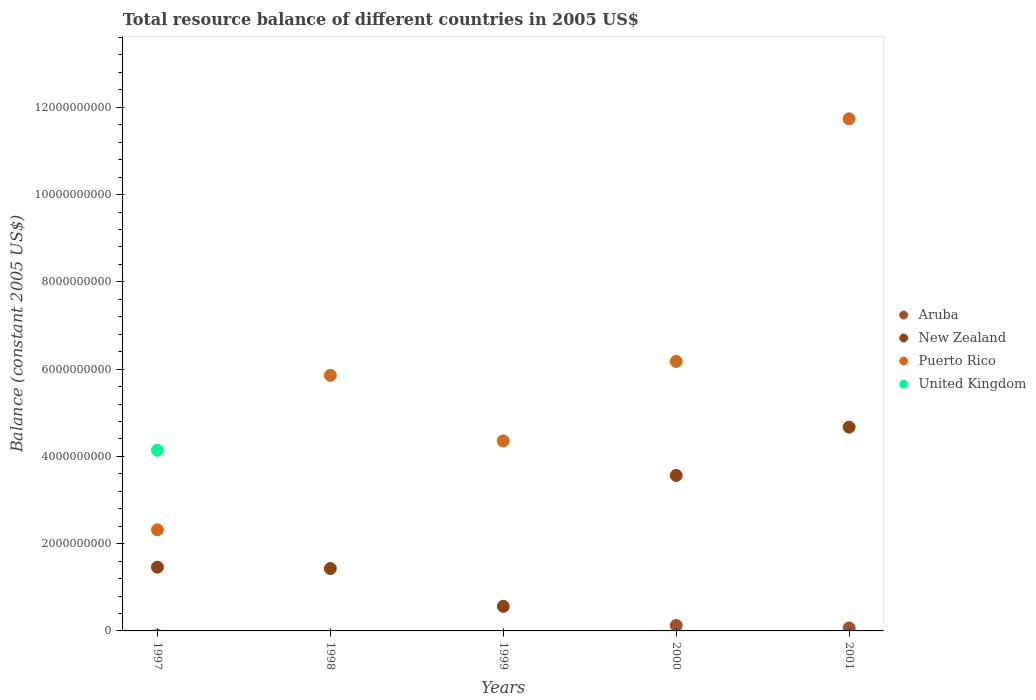How many different coloured dotlines are there?
Ensure brevity in your answer.  4. What is the total resource balance in Puerto Rico in 1999?
Your response must be concise. 4.35e+09. Across all years, what is the maximum total resource balance in New Zealand?
Keep it short and to the point. 4.67e+09. Across all years, what is the minimum total resource balance in New Zealand?
Your answer should be very brief. 5.63e+08. In which year was the total resource balance in United Kingdom maximum?
Your response must be concise. 1997. What is the total total resource balance in New Zealand in the graph?
Give a very brief answer. 1.17e+1. What is the difference between the total resource balance in New Zealand in 1999 and that in 2001?
Your answer should be very brief. -4.11e+09. What is the difference between the total resource balance in United Kingdom in 1997 and the total resource balance in Puerto Rico in 1999?
Provide a succinct answer. -2.14e+08. What is the average total resource balance in United Kingdom per year?
Your response must be concise. 8.28e+08. In the year 2001, what is the difference between the total resource balance in Puerto Rico and total resource balance in New Zealand?
Provide a succinct answer. 7.07e+09. What is the ratio of the total resource balance in New Zealand in 1999 to that in 2000?
Offer a very short reply. 0.16. Is the total resource balance in New Zealand in 1998 less than that in 2001?
Your answer should be compact. Yes. What is the difference between the highest and the second highest total resource balance in Puerto Rico?
Make the answer very short. 5.56e+09. What is the difference between the highest and the lowest total resource balance in Aruba?
Your answer should be compact. 1.24e+08. In how many years, is the total resource balance in Puerto Rico greater than the average total resource balance in Puerto Rico taken over all years?
Offer a terse response. 2. Is it the case that in every year, the sum of the total resource balance in New Zealand and total resource balance in Puerto Rico  is greater than the sum of total resource balance in United Kingdom and total resource balance in Aruba?
Your answer should be very brief. No. Is it the case that in every year, the sum of the total resource balance in Puerto Rico and total resource balance in United Kingdom  is greater than the total resource balance in Aruba?
Ensure brevity in your answer.  Yes. Does the total resource balance in New Zealand monotonically increase over the years?
Your answer should be compact. No. Is the total resource balance in United Kingdom strictly greater than the total resource balance in Puerto Rico over the years?
Your response must be concise. No. Is the total resource balance in Puerto Rico strictly less than the total resource balance in New Zealand over the years?
Your response must be concise. No. How many dotlines are there?
Offer a very short reply. 4. What is the difference between two consecutive major ticks on the Y-axis?
Make the answer very short. 2.00e+09. Are the values on the major ticks of Y-axis written in scientific E-notation?
Offer a terse response. No. Does the graph contain any zero values?
Keep it short and to the point. Yes. What is the title of the graph?
Give a very brief answer. Total resource balance of different countries in 2005 US$. What is the label or title of the X-axis?
Give a very brief answer. Years. What is the label or title of the Y-axis?
Make the answer very short. Balance (constant 2005 US$). What is the Balance (constant 2005 US$) of Aruba in 1997?
Keep it short and to the point. 0. What is the Balance (constant 2005 US$) in New Zealand in 1997?
Give a very brief answer. 1.46e+09. What is the Balance (constant 2005 US$) in Puerto Rico in 1997?
Your answer should be very brief. 2.32e+09. What is the Balance (constant 2005 US$) in United Kingdom in 1997?
Your answer should be compact. 4.14e+09. What is the Balance (constant 2005 US$) in Aruba in 1998?
Offer a terse response. 0. What is the Balance (constant 2005 US$) of New Zealand in 1998?
Give a very brief answer. 1.43e+09. What is the Balance (constant 2005 US$) in Puerto Rico in 1998?
Your answer should be compact. 5.86e+09. What is the Balance (constant 2005 US$) of United Kingdom in 1998?
Give a very brief answer. 0. What is the Balance (constant 2005 US$) in Aruba in 1999?
Your answer should be very brief. 0. What is the Balance (constant 2005 US$) of New Zealand in 1999?
Ensure brevity in your answer.  5.63e+08. What is the Balance (constant 2005 US$) in Puerto Rico in 1999?
Provide a succinct answer. 4.35e+09. What is the Balance (constant 2005 US$) of United Kingdom in 1999?
Provide a succinct answer. 0. What is the Balance (constant 2005 US$) in Aruba in 2000?
Offer a terse response. 1.24e+08. What is the Balance (constant 2005 US$) of New Zealand in 2000?
Offer a terse response. 3.56e+09. What is the Balance (constant 2005 US$) in Puerto Rico in 2000?
Ensure brevity in your answer.  6.18e+09. What is the Balance (constant 2005 US$) in Aruba in 2001?
Your answer should be very brief. 6.72e+07. What is the Balance (constant 2005 US$) of New Zealand in 2001?
Keep it short and to the point. 4.67e+09. What is the Balance (constant 2005 US$) in Puerto Rico in 2001?
Make the answer very short. 1.17e+1. What is the Balance (constant 2005 US$) of United Kingdom in 2001?
Your answer should be compact. 0. Across all years, what is the maximum Balance (constant 2005 US$) in Aruba?
Make the answer very short. 1.24e+08. Across all years, what is the maximum Balance (constant 2005 US$) of New Zealand?
Provide a short and direct response. 4.67e+09. Across all years, what is the maximum Balance (constant 2005 US$) in Puerto Rico?
Your answer should be compact. 1.17e+1. Across all years, what is the maximum Balance (constant 2005 US$) in United Kingdom?
Give a very brief answer. 4.14e+09. Across all years, what is the minimum Balance (constant 2005 US$) of Aruba?
Your response must be concise. 0. Across all years, what is the minimum Balance (constant 2005 US$) of New Zealand?
Provide a short and direct response. 5.63e+08. Across all years, what is the minimum Balance (constant 2005 US$) of Puerto Rico?
Your response must be concise. 2.32e+09. Across all years, what is the minimum Balance (constant 2005 US$) in United Kingdom?
Keep it short and to the point. 0. What is the total Balance (constant 2005 US$) of Aruba in the graph?
Offer a terse response. 1.91e+08. What is the total Balance (constant 2005 US$) of New Zealand in the graph?
Offer a very short reply. 1.17e+1. What is the total Balance (constant 2005 US$) of Puerto Rico in the graph?
Make the answer very short. 3.04e+1. What is the total Balance (constant 2005 US$) in United Kingdom in the graph?
Ensure brevity in your answer.  4.14e+09. What is the difference between the Balance (constant 2005 US$) in New Zealand in 1997 and that in 1998?
Give a very brief answer. 3.16e+07. What is the difference between the Balance (constant 2005 US$) of Puerto Rico in 1997 and that in 1998?
Ensure brevity in your answer.  -3.54e+09. What is the difference between the Balance (constant 2005 US$) in New Zealand in 1997 and that in 1999?
Your answer should be compact. 8.98e+08. What is the difference between the Balance (constant 2005 US$) in Puerto Rico in 1997 and that in 1999?
Make the answer very short. -2.04e+09. What is the difference between the Balance (constant 2005 US$) in New Zealand in 1997 and that in 2000?
Keep it short and to the point. -2.10e+09. What is the difference between the Balance (constant 2005 US$) in Puerto Rico in 1997 and that in 2000?
Your response must be concise. -3.86e+09. What is the difference between the Balance (constant 2005 US$) in New Zealand in 1997 and that in 2001?
Your answer should be compact. -3.21e+09. What is the difference between the Balance (constant 2005 US$) of Puerto Rico in 1997 and that in 2001?
Your answer should be very brief. -9.42e+09. What is the difference between the Balance (constant 2005 US$) in New Zealand in 1998 and that in 1999?
Offer a very short reply. 8.67e+08. What is the difference between the Balance (constant 2005 US$) of Puerto Rico in 1998 and that in 1999?
Provide a short and direct response. 1.50e+09. What is the difference between the Balance (constant 2005 US$) of New Zealand in 1998 and that in 2000?
Your answer should be very brief. -2.13e+09. What is the difference between the Balance (constant 2005 US$) of Puerto Rico in 1998 and that in 2000?
Make the answer very short. -3.19e+08. What is the difference between the Balance (constant 2005 US$) of New Zealand in 1998 and that in 2001?
Your answer should be compact. -3.24e+09. What is the difference between the Balance (constant 2005 US$) in Puerto Rico in 1998 and that in 2001?
Your response must be concise. -5.88e+09. What is the difference between the Balance (constant 2005 US$) in New Zealand in 1999 and that in 2000?
Ensure brevity in your answer.  -3.00e+09. What is the difference between the Balance (constant 2005 US$) of Puerto Rico in 1999 and that in 2000?
Offer a very short reply. -1.82e+09. What is the difference between the Balance (constant 2005 US$) of New Zealand in 1999 and that in 2001?
Make the answer very short. -4.11e+09. What is the difference between the Balance (constant 2005 US$) of Puerto Rico in 1999 and that in 2001?
Provide a short and direct response. -7.38e+09. What is the difference between the Balance (constant 2005 US$) of Aruba in 2000 and that in 2001?
Your answer should be very brief. 5.69e+07. What is the difference between the Balance (constant 2005 US$) in New Zealand in 2000 and that in 2001?
Make the answer very short. -1.11e+09. What is the difference between the Balance (constant 2005 US$) in Puerto Rico in 2000 and that in 2001?
Make the answer very short. -5.56e+09. What is the difference between the Balance (constant 2005 US$) of New Zealand in 1997 and the Balance (constant 2005 US$) of Puerto Rico in 1998?
Offer a very short reply. -4.40e+09. What is the difference between the Balance (constant 2005 US$) of New Zealand in 1997 and the Balance (constant 2005 US$) of Puerto Rico in 1999?
Offer a terse response. -2.89e+09. What is the difference between the Balance (constant 2005 US$) in New Zealand in 1997 and the Balance (constant 2005 US$) in Puerto Rico in 2000?
Your answer should be very brief. -4.71e+09. What is the difference between the Balance (constant 2005 US$) in New Zealand in 1997 and the Balance (constant 2005 US$) in Puerto Rico in 2001?
Provide a succinct answer. -1.03e+1. What is the difference between the Balance (constant 2005 US$) of New Zealand in 1998 and the Balance (constant 2005 US$) of Puerto Rico in 1999?
Ensure brevity in your answer.  -2.92e+09. What is the difference between the Balance (constant 2005 US$) in New Zealand in 1998 and the Balance (constant 2005 US$) in Puerto Rico in 2000?
Ensure brevity in your answer.  -4.75e+09. What is the difference between the Balance (constant 2005 US$) in New Zealand in 1998 and the Balance (constant 2005 US$) in Puerto Rico in 2001?
Your answer should be compact. -1.03e+1. What is the difference between the Balance (constant 2005 US$) in New Zealand in 1999 and the Balance (constant 2005 US$) in Puerto Rico in 2000?
Keep it short and to the point. -5.61e+09. What is the difference between the Balance (constant 2005 US$) of New Zealand in 1999 and the Balance (constant 2005 US$) of Puerto Rico in 2001?
Your response must be concise. -1.12e+1. What is the difference between the Balance (constant 2005 US$) of Aruba in 2000 and the Balance (constant 2005 US$) of New Zealand in 2001?
Make the answer very short. -4.55e+09. What is the difference between the Balance (constant 2005 US$) in Aruba in 2000 and the Balance (constant 2005 US$) in Puerto Rico in 2001?
Provide a short and direct response. -1.16e+1. What is the difference between the Balance (constant 2005 US$) in New Zealand in 2000 and the Balance (constant 2005 US$) in Puerto Rico in 2001?
Give a very brief answer. -8.17e+09. What is the average Balance (constant 2005 US$) in Aruba per year?
Keep it short and to the point. 3.82e+07. What is the average Balance (constant 2005 US$) of New Zealand per year?
Your response must be concise. 2.34e+09. What is the average Balance (constant 2005 US$) in Puerto Rico per year?
Offer a very short reply. 6.09e+09. What is the average Balance (constant 2005 US$) of United Kingdom per year?
Provide a succinct answer. 8.28e+08. In the year 1997, what is the difference between the Balance (constant 2005 US$) in New Zealand and Balance (constant 2005 US$) in Puerto Rico?
Make the answer very short. -8.56e+08. In the year 1997, what is the difference between the Balance (constant 2005 US$) in New Zealand and Balance (constant 2005 US$) in United Kingdom?
Offer a terse response. -2.68e+09. In the year 1997, what is the difference between the Balance (constant 2005 US$) in Puerto Rico and Balance (constant 2005 US$) in United Kingdom?
Provide a succinct answer. -1.82e+09. In the year 1998, what is the difference between the Balance (constant 2005 US$) in New Zealand and Balance (constant 2005 US$) in Puerto Rico?
Give a very brief answer. -4.43e+09. In the year 1999, what is the difference between the Balance (constant 2005 US$) in New Zealand and Balance (constant 2005 US$) in Puerto Rico?
Offer a very short reply. -3.79e+09. In the year 2000, what is the difference between the Balance (constant 2005 US$) in Aruba and Balance (constant 2005 US$) in New Zealand?
Give a very brief answer. -3.44e+09. In the year 2000, what is the difference between the Balance (constant 2005 US$) in Aruba and Balance (constant 2005 US$) in Puerto Rico?
Offer a terse response. -6.05e+09. In the year 2000, what is the difference between the Balance (constant 2005 US$) of New Zealand and Balance (constant 2005 US$) of Puerto Rico?
Make the answer very short. -2.61e+09. In the year 2001, what is the difference between the Balance (constant 2005 US$) of Aruba and Balance (constant 2005 US$) of New Zealand?
Offer a terse response. -4.60e+09. In the year 2001, what is the difference between the Balance (constant 2005 US$) of Aruba and Balance (constant 2005 US$) of Puerto Rico?
Offer a terse response. -1.17e+1. In the year 2001, what is the difference between the Balance (constant 2005 US$) in New Zealand and Balance (constant 2005 US$) in Puerto Rico?
Offer a very short reply. -7.07e+09. What is the ratio of the Balance (constant 2005 US$) of New Zealand in 1997 to that in 1998?
Keep it short and to the point. 1.02. What is the ratio of the Balance (constant 2005 US$) of Puerto Rico in 1997 to that in 1998?
Provide a short and direct response. 0.4. What is the ratio of the Balance (constant 2005 US$) in New Zealand in 1997 to that in 1999?
Your response must be concise. 2.6. What is the ratio of the Balance (constant 2005 US$) of Puerto Rico in 1997 to that in 1999?
Make the answer very short. 0.53. What is the ratio of the Balance (constant 2005 US$) in New Zealand in 1997 to that in 2000?
Make the answer very short. 0.41. What is the ratio of the Balance (constant 2005 US$) in Puerto Rico in 1997 to that in 2000?
Offer a very short reply. 0.38. What is the ratio of the Balance (constant 2005 US$) of New Zealand in 1997 to that in 2001?
Provide a succinct answer. 0.31. What is the ratio of the Balance (constant 2005 US$) in Puerto Rico in 1997 to that in 2001?
Offer a very short reply. 0.2. What is the ratio of the Balance (constant 2005 US$) in New Zealand in 1998 to that in 1999?
Your response must be concise. 2.54. What is the ratio of the Balance (constant 2005 US$) of Puerto Rico in 1998 to that in 1999?
Give a very brief answer. 1.35. What is the ratio of the Balance (constant 2005 US$) of New Zealand in 1998 to that in 2000?
Your answer should be very brief. 0.4. What is the ratio of the Balance (constant 2005 US$) of Puerto Rico in 1998 to that in 2000?
Offer a very short reply. 0.95. What is the ratio of the Balance (constant 2005 US$) of New Zealand in 1998 to that in 2001?
Offer a terse response. 0.31. What is the ratio of the Balance (constant 2005 US$) of Puerto Rico in 1998 to that in 2001?
Keep it short and to the point. 0.5. What is the ratio of the Balance (constant 2005 US$) of New Zealand in 1999 to that in 2000?
Make the answer very short. 0.16. What is the ratio of the Balance (constant 2005 US$) in Puerto Rico in 1999 to that in 2000?
Provide a succinct answer. 0.7. What is the ratio of the Balance (constant 2005 US$) of New Zealand in 1999 to that in 2001?
Your answer should be compact. 0.12. What is the ratio of the Balance (constant 2005 US$) in Puerto Rico in 1999 to that in 2001?
Provide a short and direct response. 0.37. What is the ratio of the Balance (constant 2005 US$) in Aruba in 2000 to that in 2001?
Offer a very short reply. 1.85. What is the ratio of the Balance (constant 2005 US$) of New Zealand in 2000 to that in 2001?
Your answer should be very brief. 0.76. What is the ratio of the Balance (constant 2005 US$) of Puerto Rico in 2000 to that in 2001?
Provide a short and direct response. 0.53. What is the difference between the highest and the second highest Balance (constant 2005 US$) in New Zealand?
Your response must be concise. 1.11e+09. What is the difference between the highest and the second highest Balance (constant 2005 US$) in Puerto Rico?
Your answer should be compact. 5.56e+09. What is the difference between the highest and the lowest Balance (constant 2005 US$) in Aruba?
Your answer should be very brief. 1.24e+08. What is the difference between the highest and the lowest Balance (constant 2005 US$) of New Zealand?
Ensure brevity in your answer.  4.11e+09. What is the difference between the highest and the lowest Balance (constant 2005 US$) in Puerto Rico?
Your answer should be very brief. 9.42e+09. What is the difference between the highest and the lowest Balance (constant 2005 US$) in United Kingdom?
Offer a very short reply. 4.14e+09. 